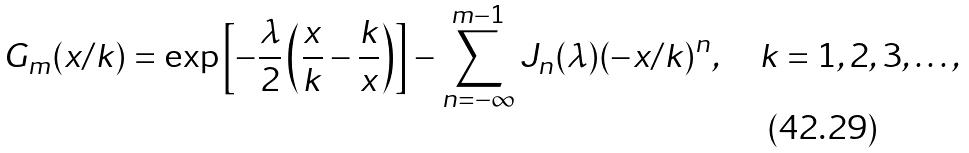Convert formula to latex. <formula><loc_0><loc_0><loc_500><loc_500>G _ { m } ( x / k ) = \exp \left [ - \frac { \lambda } { 2 } \left ( \frac { x } { k } - \frac { k } { x } \right ) \right ] - \sum _ { n = - \infty } ^ { m - 1 } J _ { n } ( \lambda ) ( - x / k ) ^ { n } , \quad k = 1 , 2 , 3 , \dots ,</formula> 